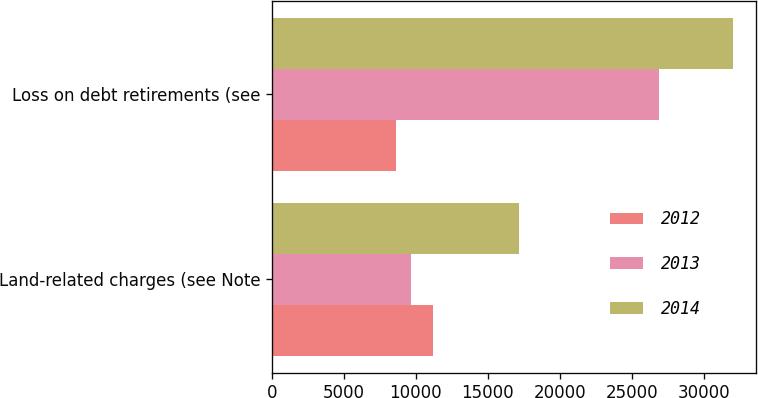<chart> <loc_0><loc_0><loc_500><loc_500><stacked_bar_chart><ecel><fcel>Land-related charges (see Note<fcel>Loss on debt retirements (see<nl><fcel>2012<fcel>11168<fcel>8584<nl><fcel>2013<fcel>9672<fcel>26930<nl><fcel>2014<fcel>17195<fcel>32071<nl></chart> 